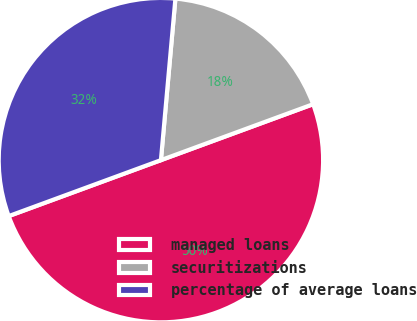<chart> <loc_0><loc_0><loc_500><loc_500><pie_chart><fcel>managed loans<fcel>securitizations<fcel>percentage of average loans<nl><fcel>50.0%<fcel>17.97%<fcel>32.03%<nl></chart> 